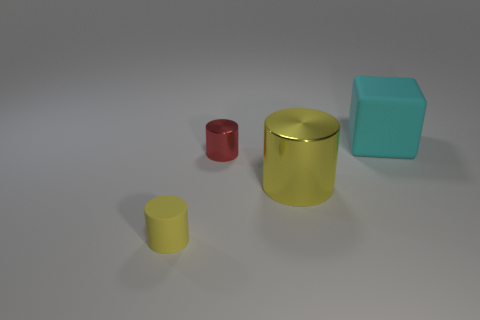The big rubber cube is what color? The large cube in the image has a distinct shade of cyan, which is reminiscent of a light, blue-green color commonly associated with the feeling of tranquility. 